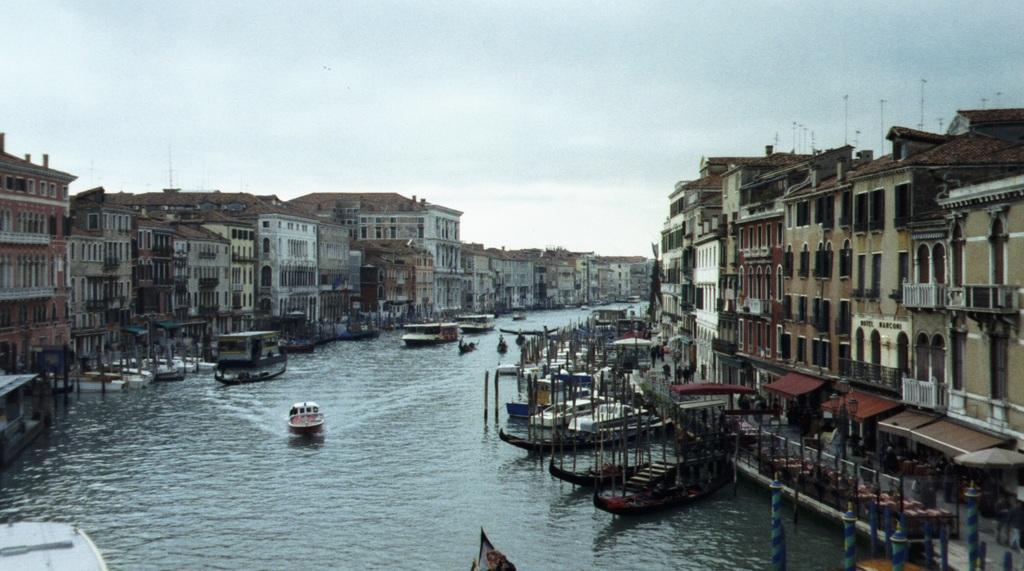In one or two sentences, can you explain what this image depicts? In the center of the image there are boats sailing on the river. On the right side of the image there are buildings and persons. On the left side of the image there are buildings, persons, boats and poles. In the background there is a sky. 